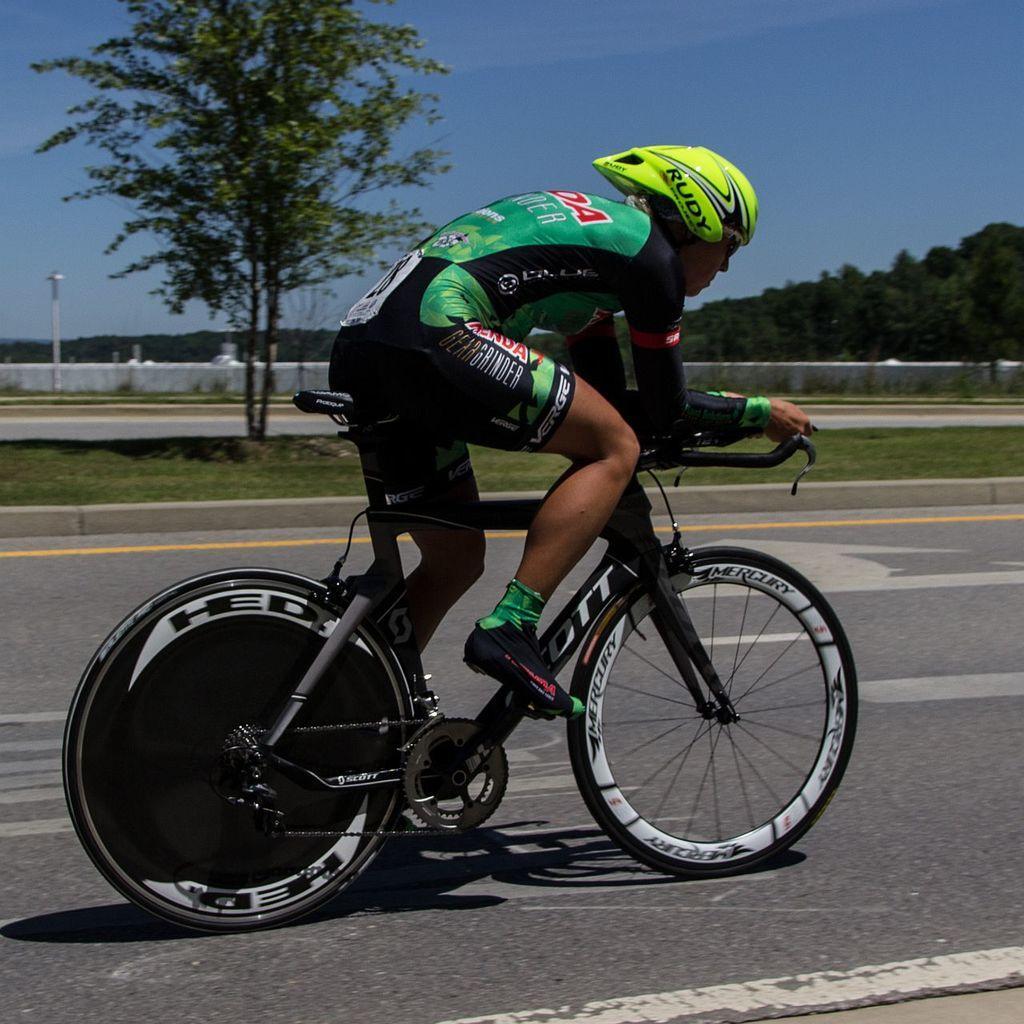Please provide a concise description of this image. There is a person in the center of the image on a bicycle and there are trees, grassland, poles and sky in the background area. 